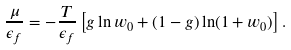Convert formula to latex. <formula><loc_0><loc_0><loc_500><loc_500>\frac { \mu } { \epsilon _ { f } } = - \frac { T } { \epsilon _ { f } } \left [ g \ln w _ { 0 } + ( 1 - g ) \ln ( 1 + w _ { 0 } ) \right ] .</formula> 